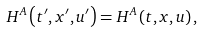Convert formula to latex. <formula><loc_0><loc_0><loc_500><loc_500>H ^ { A } \left ( t ^ { \prime } , x ^ { \prime } , u ^ { \prime } \right ) = H ^ { A } \left ( t , x , u \right ) ,</formula> 